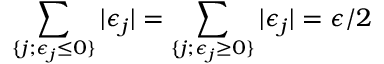Convert formula to latex. <formula><loc_0><loc_0><loc_500><loc_500>\sum _ { \{ j ; \epsilon _ { j } \leq 0 \} } | \epsilon _ { j } | = \sum _ { \{ j ; \epsilon _ { j } \geq 0 \} } | \epsilon _ { j } | = \epsilon / 2</formula> 